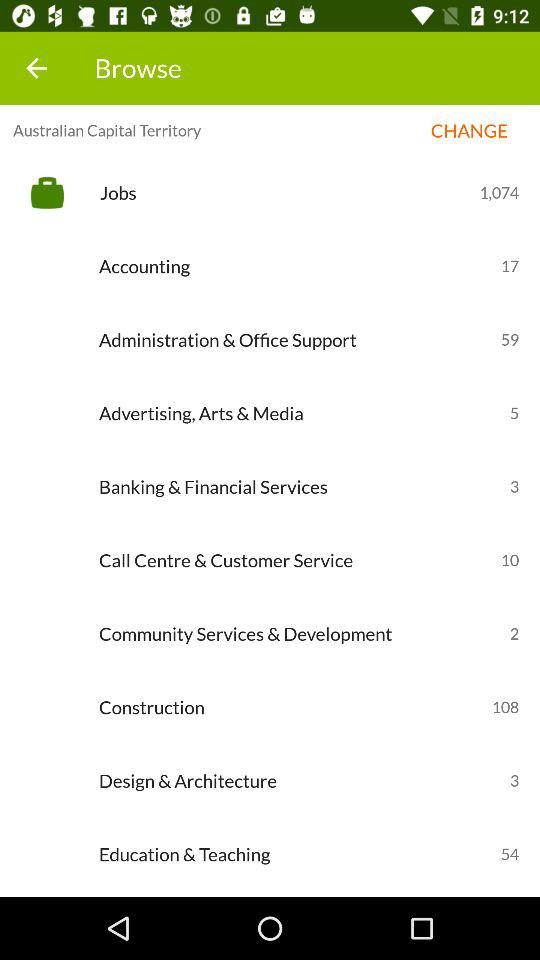What are the total jobs available? There are 1,074 total available jobs. 